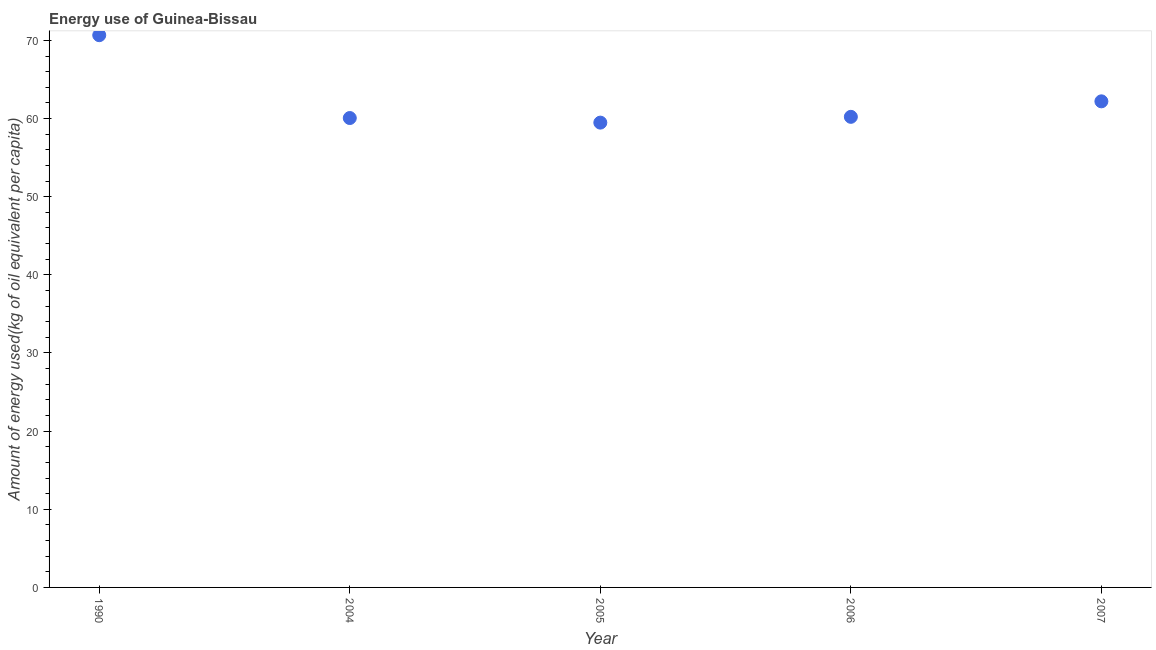What is the amount of energy used in 2004?
Make the answer very short. 60.06. Across all years, what is the maximum amount of energy used?
Your response must be concise. 70.66. Across all years, what is the minimum amount of energy used?
Your answer should be compact. 59.48. In which year was the amount of energy used minimum?
Your answer should be compact. 2005. What is the sum of the amount of energy used?
Your answer should be very brief. 312.62. What is the difference between the amount of energy used in 1990 and 2005?
Offer a terse response. 11.19. What is the average amount of energy used per year?
Offer a terse response. 62.52. What is the median amount of energy used?
Offer a very short reply. 60.22. In how many years, is the amount of energy used greater than 52 kg?
Your answer should be very brief. 5. Do a majority of the years between 2004 and 1990 (inclusive) have amount of energy used greater than 14 kg?
Make the answer very short. No. What is the ratio of the amount of energy used in 1990 to that in 2005?
Provide a succinct answer. 1.19. Is the difference between the amount of energy used in 1990 and 2004 greater than the difference between any two years?
Keep it short and to the point. No. What is the difference between the highest and the second highest amount of energy used?
Offer a terse response. 8.46. What is the difference between the highest and the lowest amount of energy used?
Your answer should be compact. 11.19. In how many years, is the amount of energy used greater than the average amount of energy used taken over all years?
Offer a terse response. 1. Are the values on the major ticks of Y-axis written in scientific E-notation?
Your answer should be very brief. No. What is the title of the graph?
Offer a very short reply. Energy use of Guinea-Bissau. What is the label or title of the Y-axis?
Your response must be concise. Amount of energy used(kg of oil equivalent per capita). What is the Amount of energy used(kg of oil equivalent per capita) in 1990?
Your response must be concise. 70.66. What is the Amount of energy used(kg of oil equivalent per capita) in 2004?
Ensure brevity in your answer.  60.06. What is the Amount of energy used(kg of oil equivalent per capita) in 2005?
Your answer should be very brief. 59.48. What is the Amount of energy used(kg of oil equivalent per capita) in 2006?
Your response must be concise. 60.22. What is the Amount of energy used(kg of oil equivalent per capita) in 2007?
Ensure brevity in your answer.  62.2. What is the difference between the Amount of energy used(kg of oil equivalent per capita) in 1990 and 2004?
Your response must be concise. 10.6. What is the difference between the Amount of energy used(kg of oil equivalent per capita) in 1990 and 2005?
Keep it short and to the point. 11.19. What is the difference between the Amount of energy used(kg of oil equivalent per capita) in 1990 and 2006?
Your response must be concise. 10.45. What is the difference between the Amount of energy used(kg of oil equivalent per capita) in 1990 and 2007?
Provide a short and direct response. 8.46. What is the difference between the Amount of energy used(kg of oil equivalent per capita) in 2004 and 2005?
Offer a very short reply. 0.59. What is the difference between the Amount of energy used(kg of oil equivalent per capita) in 2004 and 2006?
Provide a short and direct response. -0.15. What is the difference between the Amount of energy used(kg of oil equivalent per capita) in 2004 and 2007?
Provide a succinct answer. -2.14. What is the difference between the Amount of energy used(kg of oil equivalent per capita) in 2005 and 2006?
Provide a succinct answer. -0.74. What is the difference between the Amount of energy used(kg of oil equivalent per capita) in 2005 and 2007?
Your answer should be compact. -2.72. What is the difference between the Amount of energy used(kg of oil equivalent per capita) in 2006 and 2007?
Provide a succinct answer. -1.98. What is the ratio of the Amount of energy used(kg of oil equivalent per capita) in 1990 to that in 2004?
Provide a succinct answer. 1.18. What is the ratio of the Amount of energy used(kg of oil equivalent per capita) in 1990 to that in 2005?
Ensure brevity in your answer.  1.19. What is the ratio of the Amount of energy used(kg of oil equivalent per capita) in 1990 to that in 2006?
Your answer should be compact. 1.17. What is the ratio of the Amount of energy used(kg of oil equivalent per capita) in 1990 to that in 2007?
Make the answer very short. 1.14. What is the ratio of the Amount of energy used(kg of oil equivalent per capita) in 2005 to that in 2006?
Give a very brief answer. 0.99. What is the ratio of the Amount of energy used(kg of oil equivalent per capita) in 2005 to that in 2007?
Your response must be concise. 0.96. What is the ratio of the Amount of energy used(kg of oil equivalent per capita) in 2006 to that in 2007?
Provide a short and direct response. 0.97. 